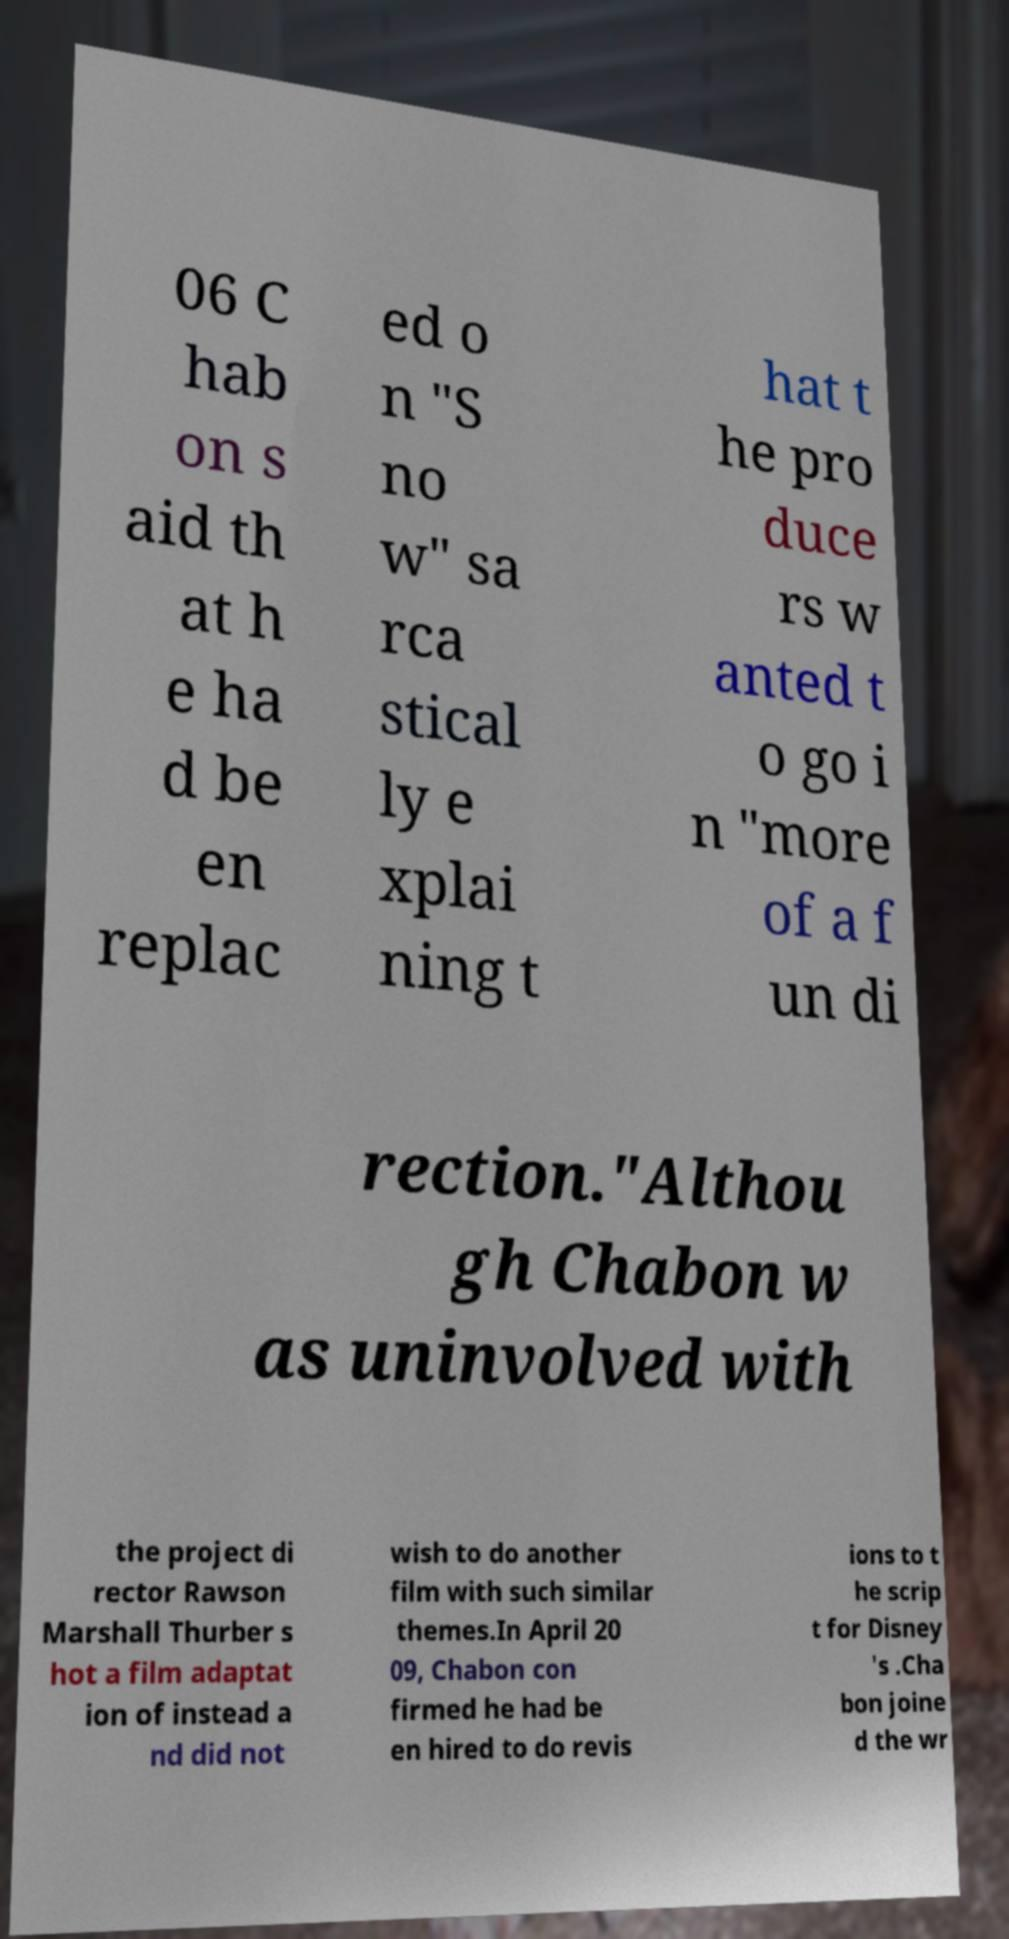Please identify and transcribe the text found in this image. 06 C hab on s aid th at h e ha d be en replac ed o n "S no w" sa rca stical ly e xplai ning t hat t he pro duce rs w anted t o go i n "more of a f un di rection."Althou gh Chabon w as uninvolved with the project di rector Rawson Marshall Thurber s hot a film adaptat ion of instead a nd did not wish to do another film with such similar themes.In April 20 09, Chabon con firmed he had be en hired to do revis ions to t he scrip t for Disney 's .Cha bon joine d the wr 